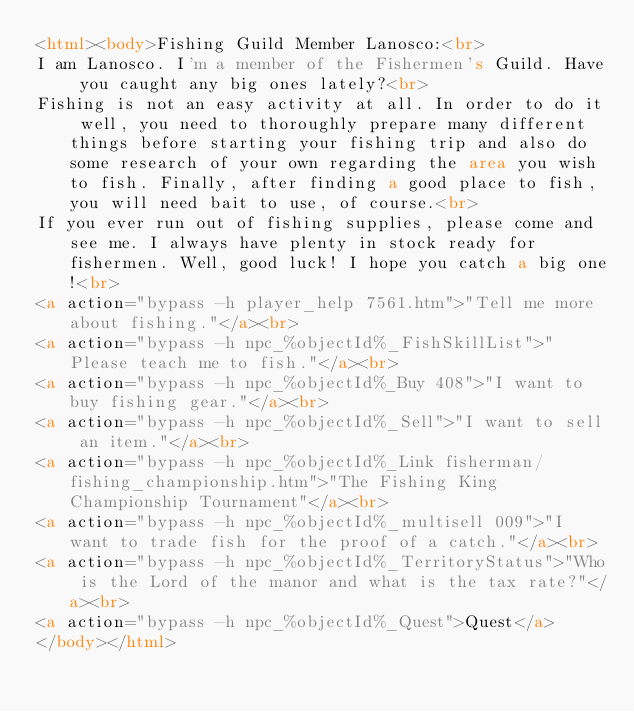Convert code to text. <code><loc_0><loc_0><loc_500><loc_500><_HTML_><html><body>Fishing Guild Member Lanosco:<br>
I am Lanosco. I'm a member of the Fishermen's Guild. Have you caught any big ones lately?<br>
Fishing is not an easy activity at all. In order to do it well, you need to thoroughly prepare many different things before starting your fishing trip and also do some research of your own regarding the area you wish to fish. Finally, after finding a good place to fish, you will need bait to use, of course.<br>
If you ever run out of fishing supplies, please come and see me. I always have plenty in stock ready for fishermen. Well, good luck! I hope you catch a big one!<br>
<a action="bypass -h player_help 7561.htm">"Tell me more about fishing."</a><br>
<a action="bypass -h npc_%objectId%_FishSkillList">"Please teach me to fish."</a><br>
<a action="bypass -h npc_%objectId%_Buy 408">"I want to buy fishing gear."</a><br>
<a action="bypass -h npc_%objectId%_Sell">"I want to sell an item."</a><br>
<a action="bypass -h npc_%objectId%_Link fisherman/fishing_championship.htm">"The Fishing King Championship Tournament"</a><br>
<a action="bypass -h npc_%objectId%_multisell 009">"I want to trade fish for the proof of a catch."</a><br>
<a action="bypass -h npc_%objectId%_TerritoryStatus">"Who is the Lord of the manor and what is the tax rate?"</a><br>
<a action="bypass -h npc_%objectId%_Quest">Quest</a>
</body></html></code> 